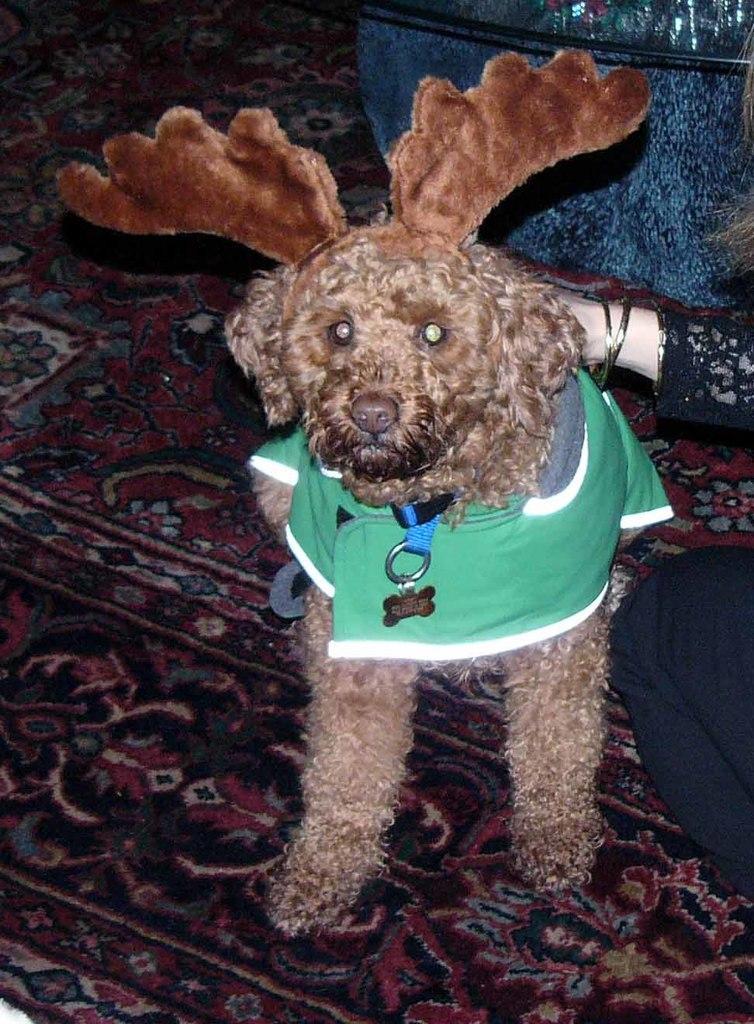Describe this image in one or two sentences. This is dog, hear a person is sitting on the mat. 